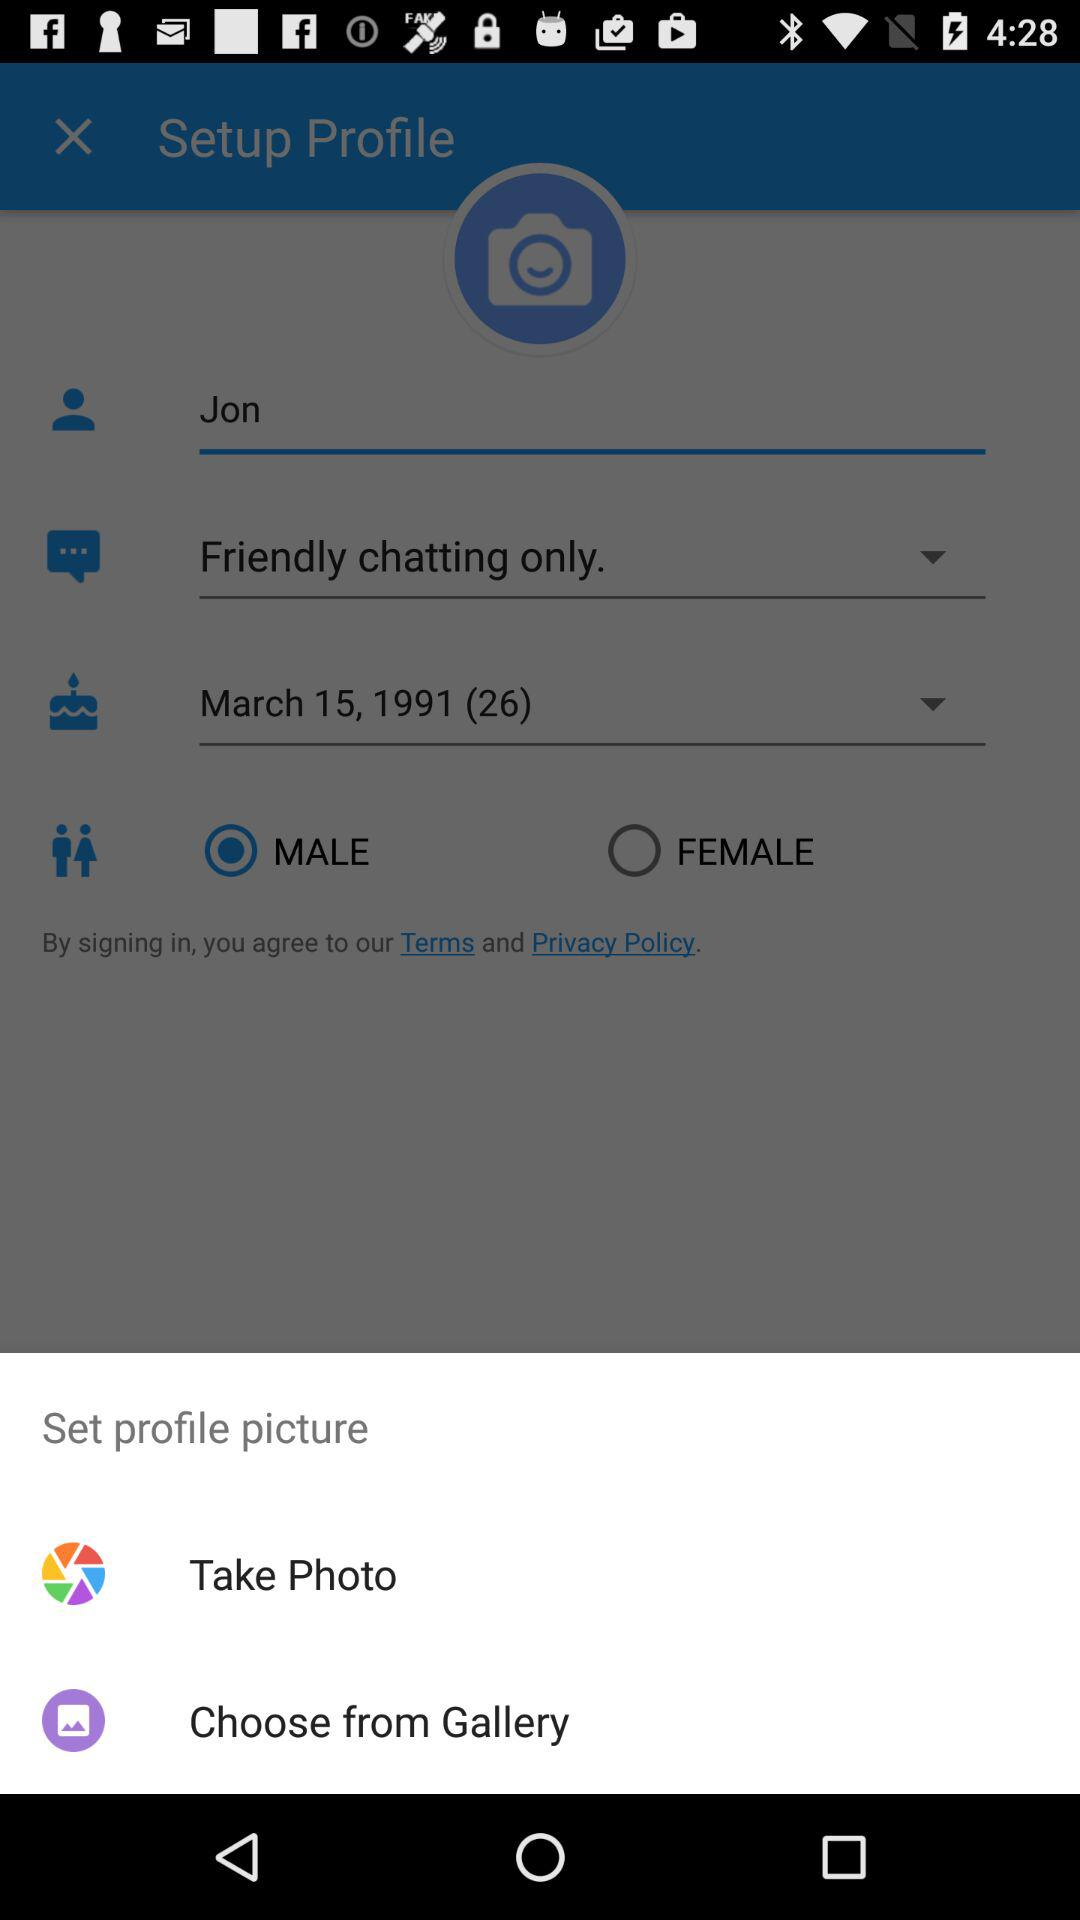Which are the options to select a profile photo? The options to select a profile photo are "Take Photo" and "Choose from Gallery". 